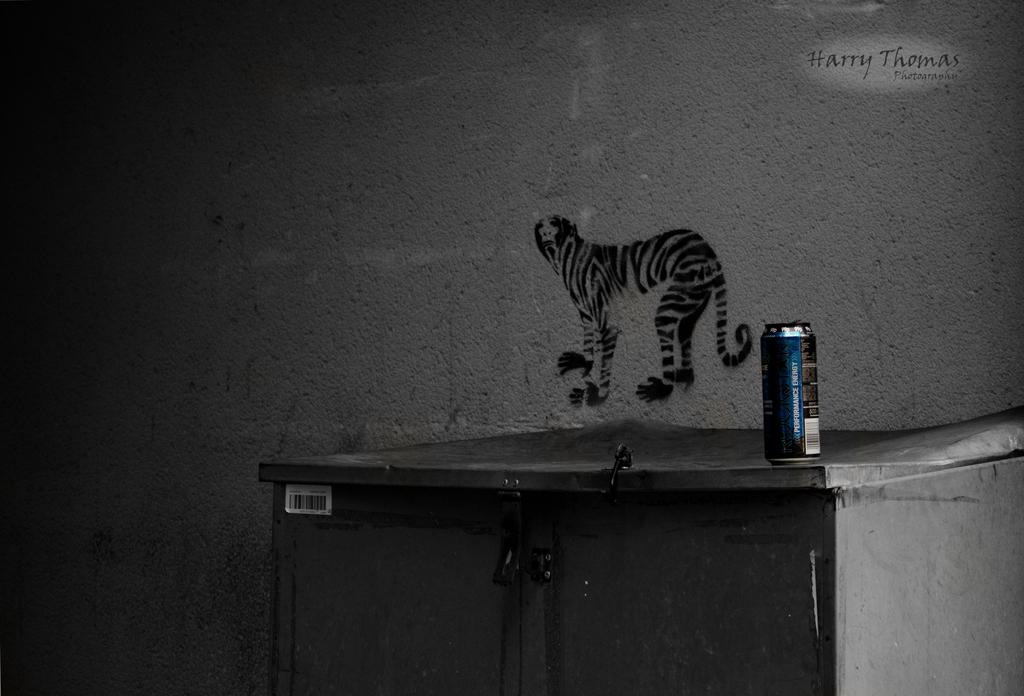What type of furniture is present in the image? There is a cupboard in the image. What object is placed on the cupboard? A soda can is placed on the cupboard. Can you describe the background of the image? There is a painting of an animal on the wall in the background. What is the reaction of the fowl to the soda can in the image? There is no fowl present in the image, so it is not possible to determine its reaction to the soda can. 